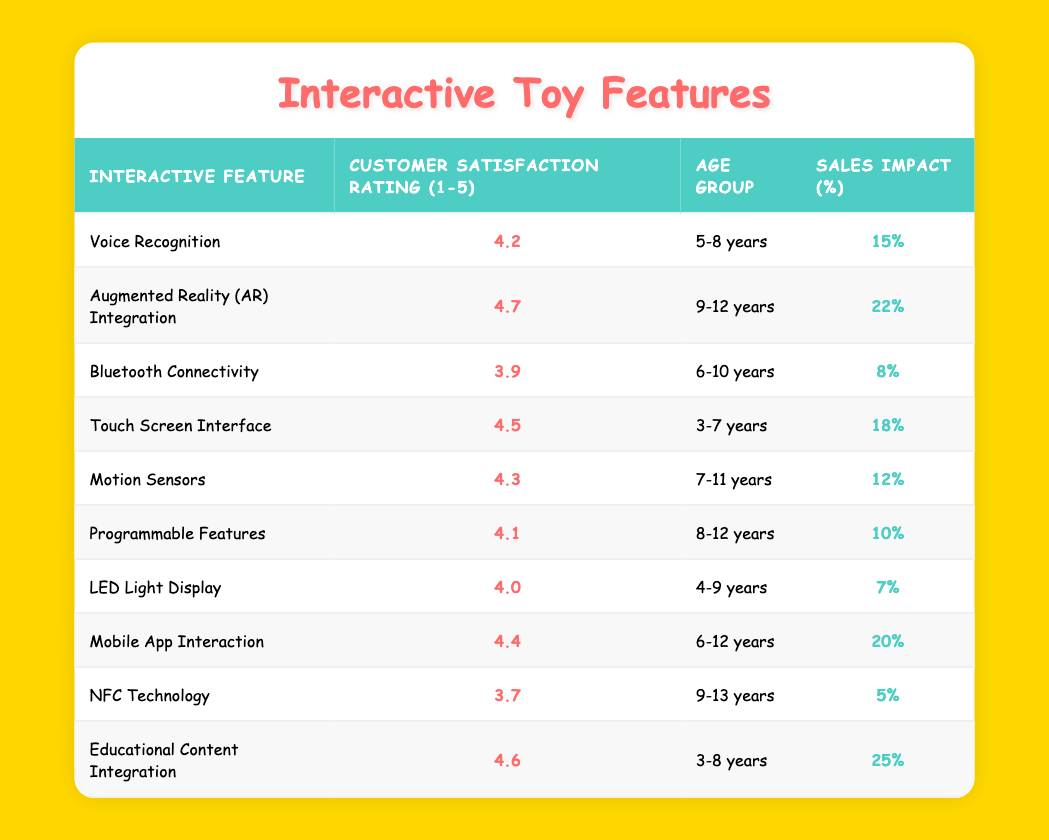What is the customer satisfaction rating for Augmented Reality (AR) Integration? The table shows that the customer satisfaction rating for Augmented Reality (AR) Integration is 4.7.
Answer: 4.7 Which interactive feature has the highest sales impact? By examining the table, the interactive feature with the highest sales impact is Educational Content Integration, which has a sales impact of 25%.
Answer: Educational Content Integration True or False: Bluetooth Connectivity has a lower customer satisfaction rating than NFC Technology. Comparing the ratings, Bluetooth Connectivity has a rating of 3.9, while NFC Technology has a rating of 3.7. Therefore, the statement is true.
Answer: True What is the average customer satisfaction rating for features designed for the 3-8 years age group? The features for the 3-8 years age group are Touch Screen Interface (4.5), Educational Content Integration (4.6), and Voice Recognition (4.2). To find the average, sum these ratings: (4.5 + 4.6 + 4.2) = 13.3. The average rating is then 13.3 divided by 3, which equals approximately 4.43.
Answer: 4.43 Which age group enjoys the Motion Sensors feature, and what is its customer satisfaction rating? According to the table, Motion Sensors are designed for the 7-11 years age group, and its customer satisfaction rating is 4.3.
Answer: 7-11 years; 4.3 How does the sales impact of Mobile App Interaction compare to that of Voice Recognition? The sales impact for Mobile App Interaction is 20%, while for Voice Recognition, it is 15%. Mobile App Interaction has a higher sales impact than Voice Recognition by 5%.
Answer: Higher by 5% What is the lowest customer satisfaction rating for any interactive feature, and which feature has this rating? By scanning the table, the lowest customer satisfaction rating is 3.7, which corresponds to the NFC Technology feature.
Answer: 3.7; NFC Technology True or False: The Touch Screen Interface is rated higher than the Programmable Features. The Touch Screen Interface has a rating of 4.5, while Programmable Features have a rating of 4.1. Since 4.5 is greater than 4.1, the statement is true.
Answer: True 